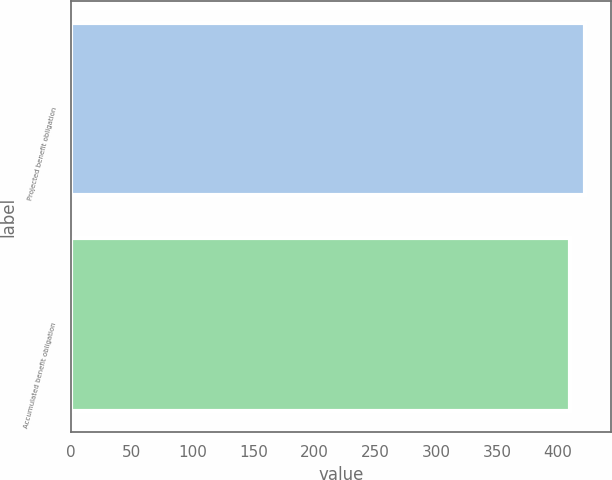<chart> <loc_0><loc_0><loc_500><loc_500><bar_chart><fcel>Projected benefit obligation<fcel>Accumulated benefit obligation<nl><fcel>422.6<fcel>409.7<nl></chart> 